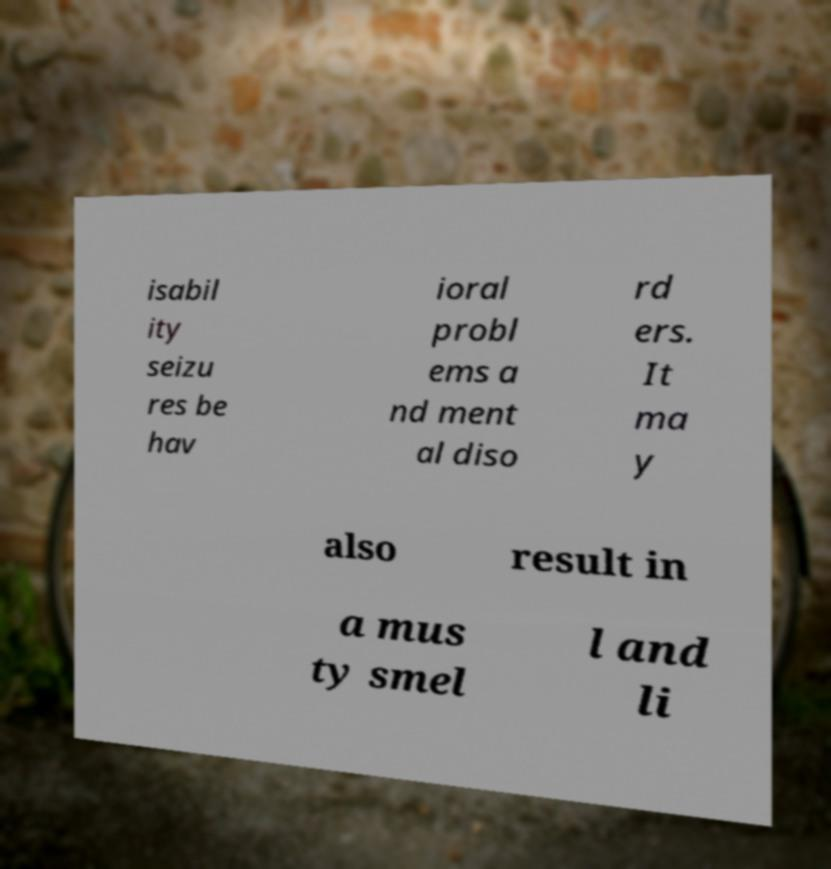What messages or text are displayed in this image? I need them in a readable, typed format. isabil ity seizu res be hav ioral probl ems a nd ment al diso rd ers. It ma y also result in a mus ty smel l and li 